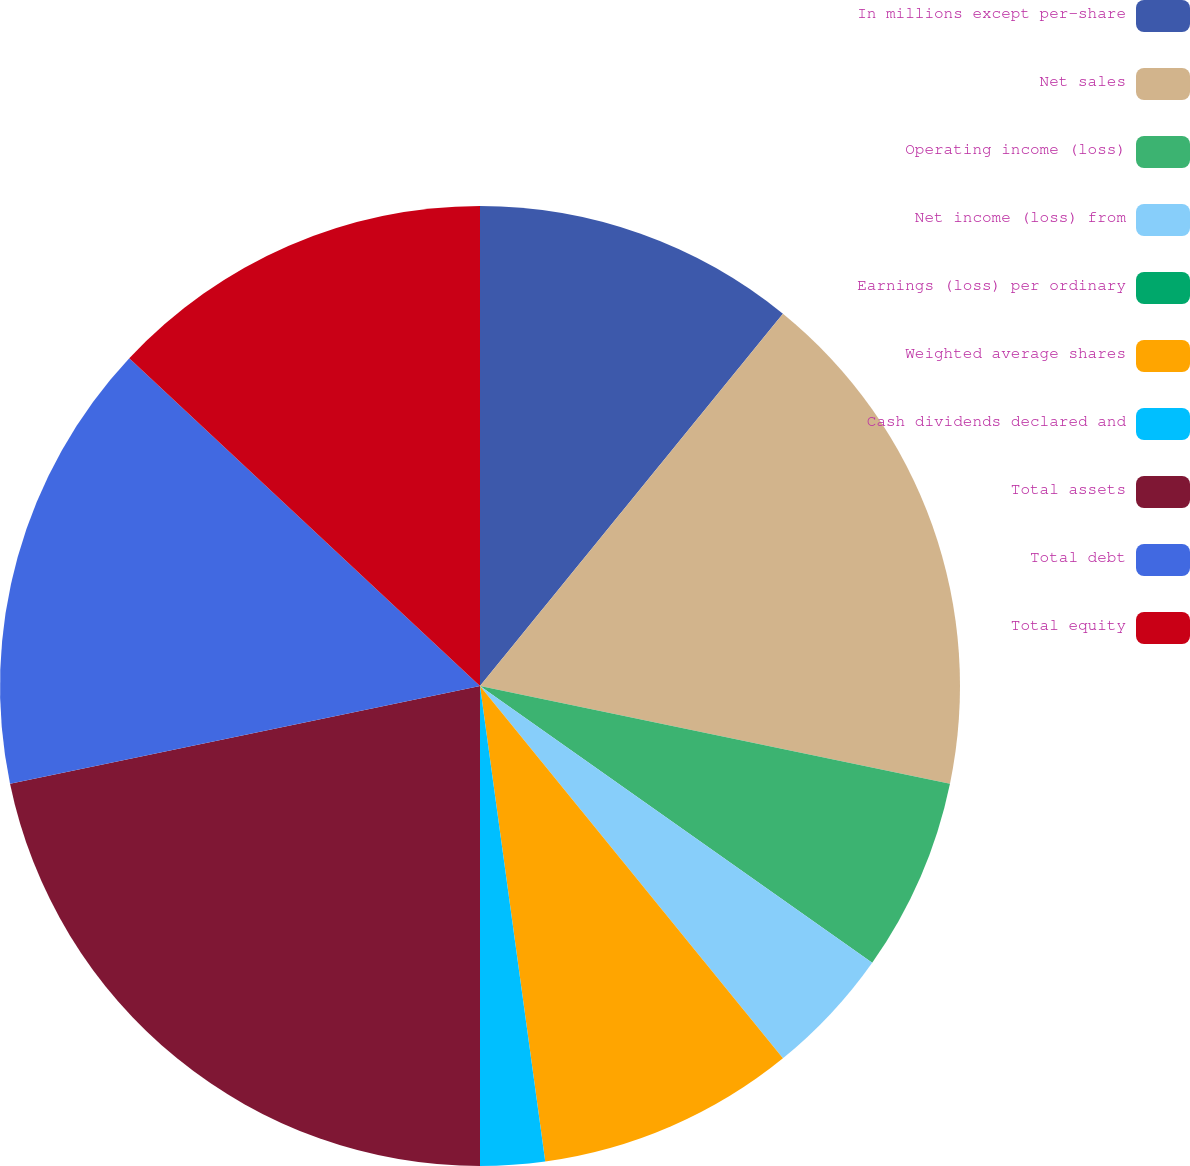<chart> <loc_0><loc_0><loc_500><loc_500><pie_chart><fcel>In millions except per-share<fcel>Net sales<fcel>Operating income (loss)<fcel>Net income (loss) from<fcel>Earnings (loss) per ordinary<fcel>Weighted average shares<fcel>Cash dividends declared and<fcel>Total assets<fcel>Total debt<fcel>Total equity<nl><fcel>10.87%<fcel>17.39%<fcel>6.52%<fcel>4.35%<fcel>0.0%<fcel>8.7%<fcel>2.17%<fcel>21.74%<fcel>15.22%<fcel>13.04%<nl></chart> 